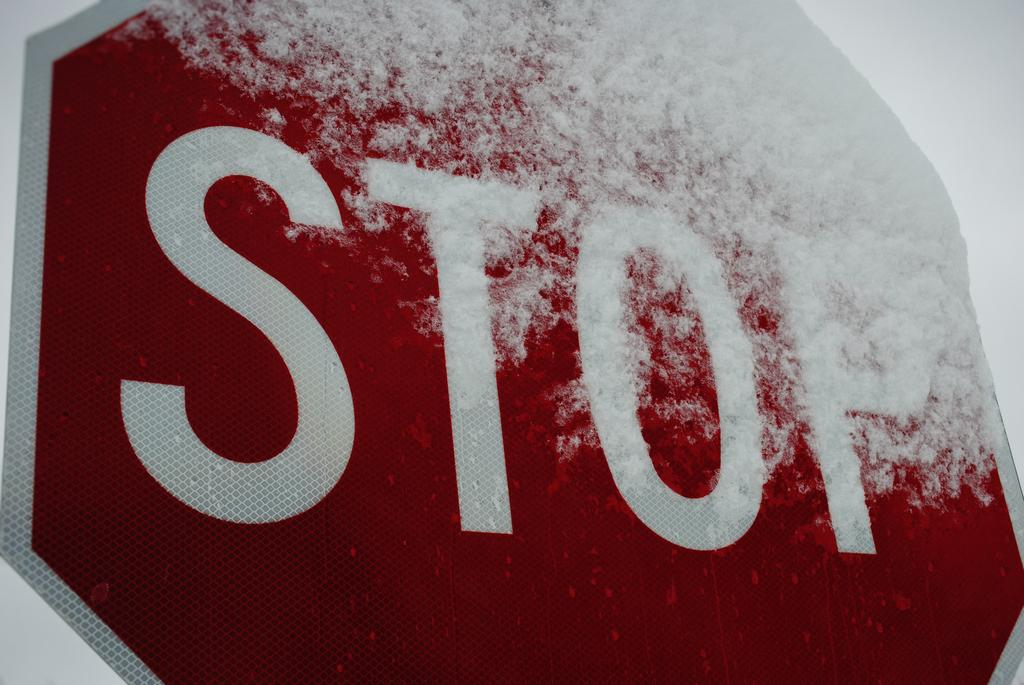<image>
Write a terse but informative summary of the picture. A closeup of a stop sign covered in snow on top. 